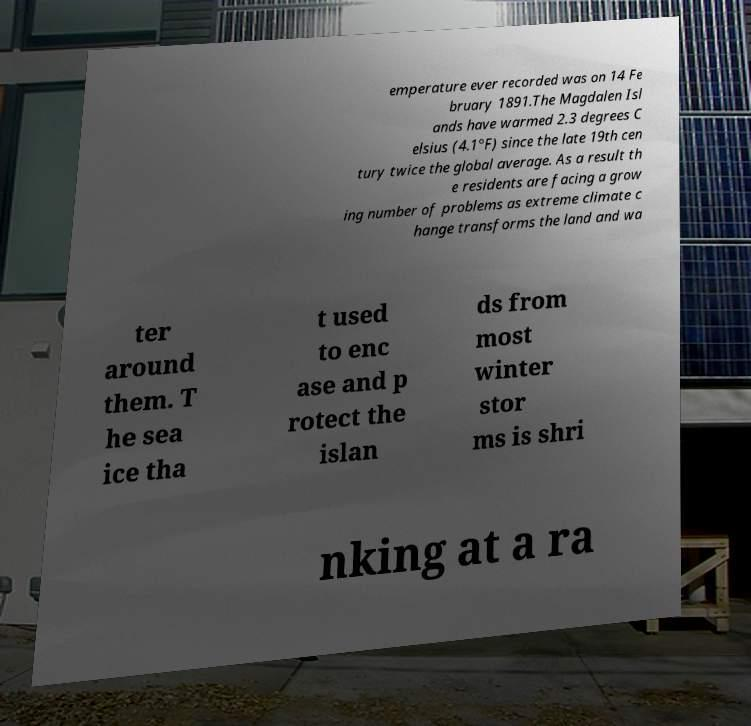I need the written content from this picture converted into text. Can you do that? emperature ever recorded was on 14 Fe bruary 1891.The Magdalen Isl ands have warmed 2.3 degrees C elsius (4.1°F) since the late 19th cen tury twice the global average. As a result th e residents are facing a grow ing number of problems as extreme climate c hange transforms the land and wa ter around them. T he sea ice tha t used to enc ase and p rotect the islan ds from most winter stor ms is shri nking at a ra 